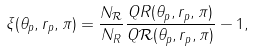Convert formula to latex. <formula><loc_0><loc_0><loc_500><loc_500>\xi ( \theta _ { p } , r _ { p } , \pi ) = \frac { N _ { \mathcal { R } } } { N _ { R } } \frac { Q R ( \theta _ { p } , r _ { p } , \pi ) } { Q \mathcal { R } ( \theta _ { p } , r _ { p } , \pi ) } - 1 ,</formula> 